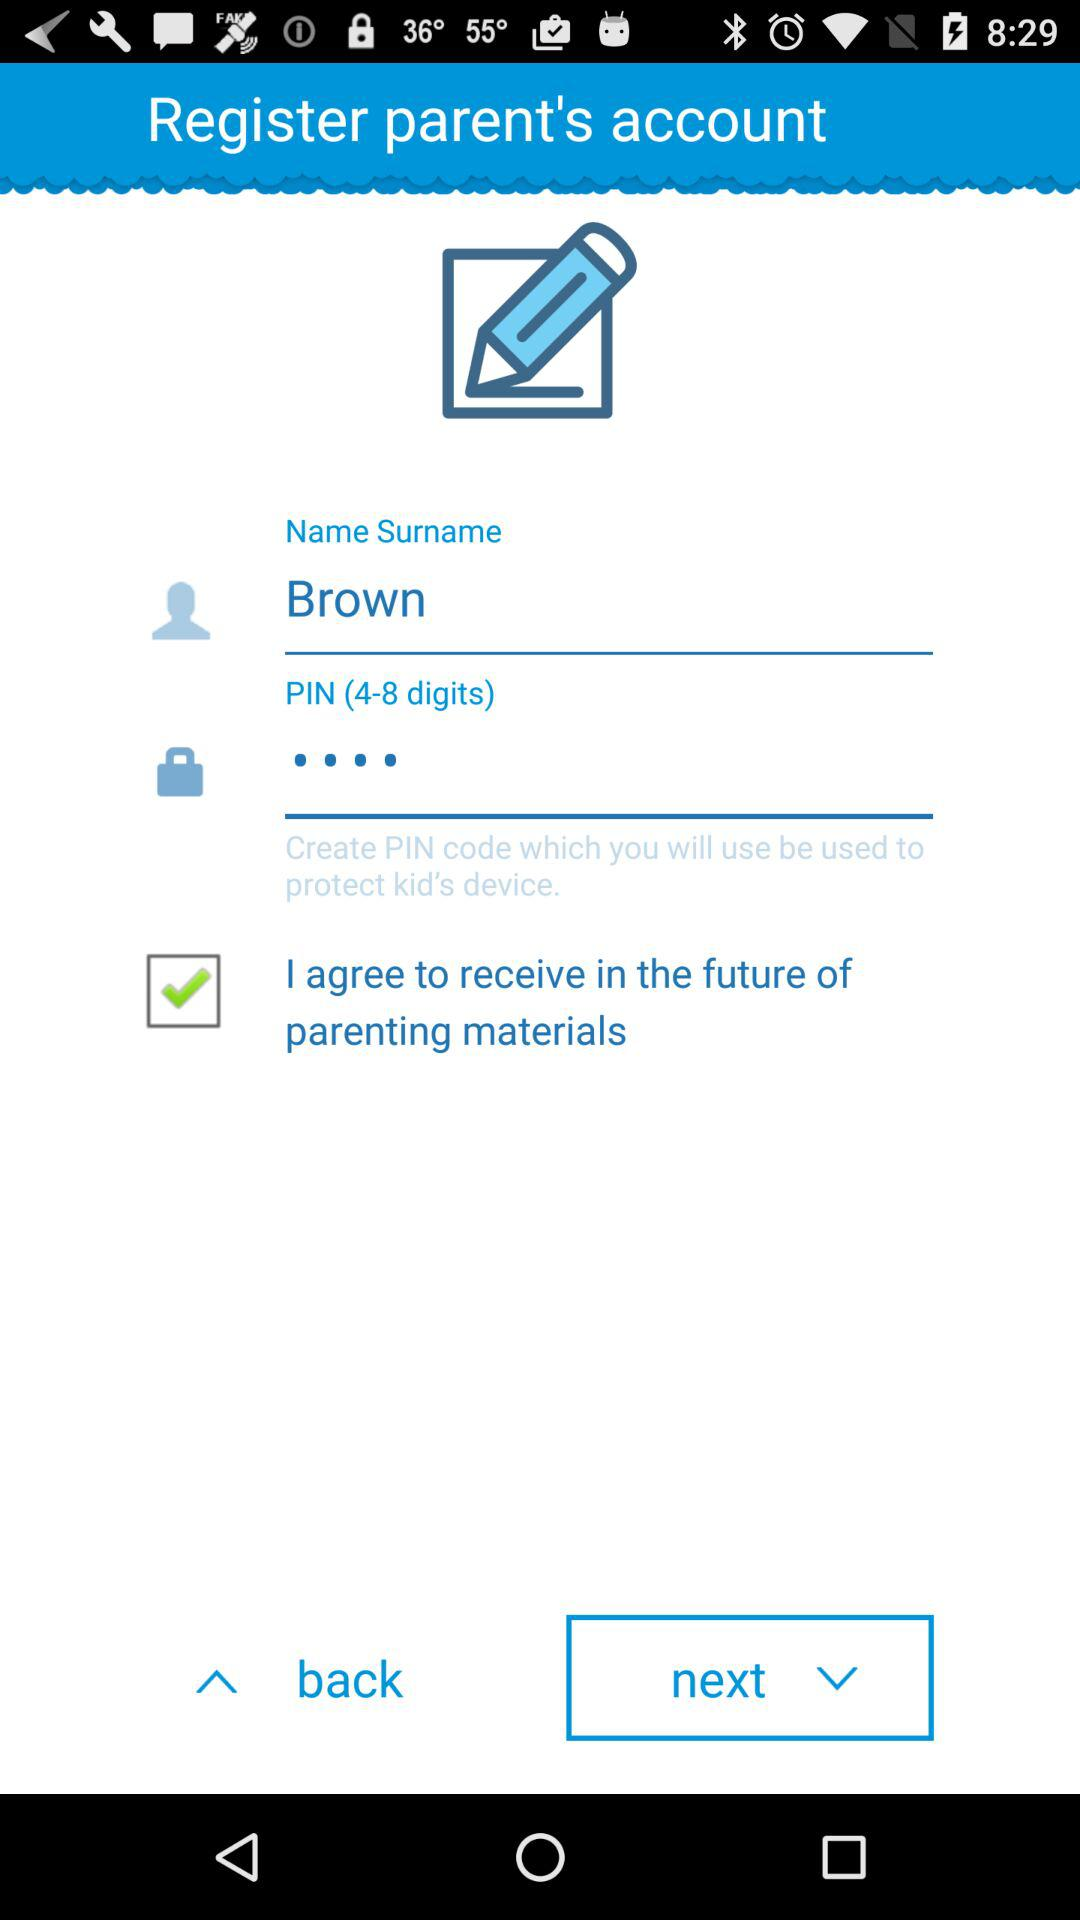For how many days will future parenting materials be sent?
When the provided information is insufficient, respond with <no answer>. <no answer> 